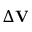Convert formula to latex. <formula><loc_0><loc_0><loc_500><loc_500>\Delta { V }</formula> 